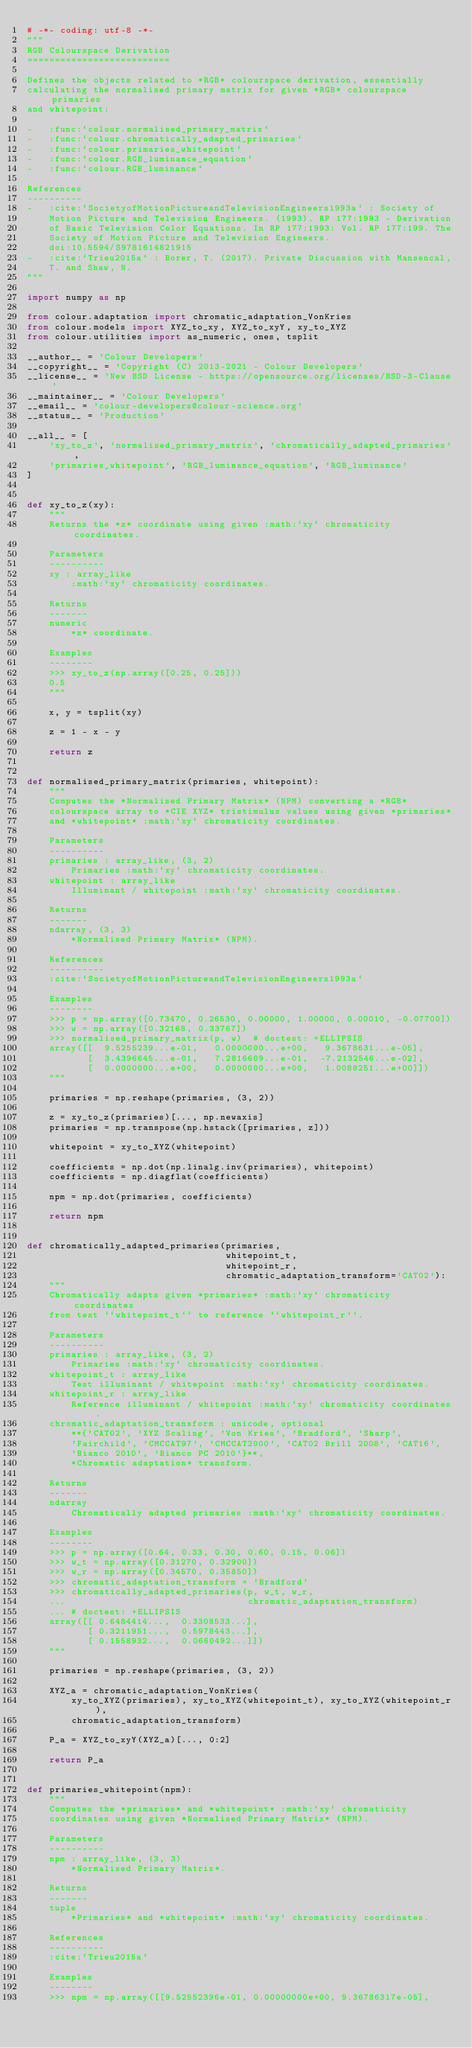Convert code to text. <code><loc_0><loc_0><loc_500><loc_500><_Python_># -*- coding: utf-8 -*-
"""
RGB Colourspace Derivation
==========================

Defines the objects related to *RGB* colourspace derivation, essentially
calculating the normalised primary matrix for given *RGB* colourspace primaries
and whitepoint:

-   :func:`colour.normalised_primary_matrix`
-   :func:`colour.chromatically_adapted_primaries`
-   :func:`colour.primaries_whitepoint`
-   :func:`colour.RGB_luminance_equation`
-   :func:`colour.RGB_luminance`

References
----------
-   :cite:`SocietyofMotionPictureandTelevisionEngineers1993a` : Society of
    Motion Picture and Television Engineers. (1993). RP 177:1993 - Derivation
    of Basic Television Color Equations. In RP 177:1993: Vol. RP 177:199. The
    Society of Motion Picture and Television Engineers.
    doi:10.5594/S9781614821915
-   :cite:`Trieu2015a` : Borer, T. (2017). Private Discussion with Mansencal,
    T. and Shaw, N.
"""

import numpy as np

from colour.adaptation import chromatic_adaptation_VonKries
from colour.models import XYZ_to_xy, XYZ_to_xyY, xy_to_XYZ
from colour.utilities import as_numeric, ones, tsplit

__author__ = 'Colour Developers'
__copyright__ = 'Copyright (C) 2013-2021 - Colour Developers'
__license__ = 'New BSD License - https://opensource.org/licenses/BSD-3-Clause'
__maintainer__ = 'Colour Developers'
__email__ = 'colour-developers@colour-science.org'
__status__ = 'Production'

__all__ = [
    'xy_to_z', 'normalised_primary_matrix', 'chromatically_adapted_primaries',
    'primaries_whitepoint', 'RGB_luminance_equation', 'RGB_luminance'
]


def xy_to_z(xy):
    """
    Returns the *z* coordinate using given :math:`xy` chromaticity coordinates.

    Parameters
    ----------
    xy : array_like
        :math:`xy` chromaticity coordinates.

    Returns
    -------
    numeric
        *z* coordinate.

    Examples
    --------
    >>> xy_to_z(np.array([0.25, 0.25]))
    0.5
    """

    x, y = tsplit(xy)

    z = 1 - x - y

    return z


def normalised_primary_matrix(primaries, whitepoint):
    """
    Computes the *Normalised Primary Matrix* (NPM) converting a *RGB*
    colourspace array to *CIE XYZ* tristimulus values using given *primaries*
    and *whitepoint* :math:`xy` chromaticity coordinates.

    Parameters
    ----------
    primaries : array_like, (3, 2)
        Primaries :math:`xy` chromaticity coordinates.
    whitepoint : array_like
        Illuminant / whitepoint :math:`xy` chromaticity coordinates.

    Returns
    -------
    ndarray, (3, 3)
        *Normalised Primary Matrix* (NPM).

    References
    ----------
    :cite:`SocietyofMotionPictureandTelevisionEngineers1993a`

    Examples
    --------
    >>> p = np.array([0.73470, 0.26530, 0.00000, 1.00000, 0.00010, -0.07700])
    >>> w = np.array([0.32168, 0.33767])
    >>> normalised_primary_matrix(p, w)  # doctest: +ELLIPSIS
    array([[  9.5255239...e-01,   0.0000000...e+00,   9.3678631...e-05],
           [  3.4396645...e-01,   7.2816609...e-01,  -7.2132546...e-02],
           [  0.0000000...e+00,   0.0000000...e+00,   1.0088251...e+00]])
    """

    primaries = np.reshape(primaries, (3, 2))

    z = xy_to_z(primaries)[..., np.newaxis]
    primaries = np.transpose(np.hstack([primaries, z]))

    whitepoint = xy_to_XYZ(whitepoint)

    coefficients = np.dot(np.linalg.inv(primaries), whitepoint)
    coefficients = np.diagflat(coefficients)

    npm = np.dot(primaries, coefficients)

    return npm


def chromatically_adapted_primaries(primaries,
                                    whitepoint_t,
                                    whitepoint_r,
                                    chromatic_adaptation_transform='CAT02'):
    """
    Chromatically adapts given *primaries* :math:`xy` chromaticity coordinates
    from test ``whitepoint_t`` to reference ``whitepoint_r``.

    Parameters
    ----------
    primaries : array_like, (3, 2)
        Primaries :math:`xy` chromaticity coordinates.
    whitepoint_t : array_like
        Test illuminant / whitepoint :math:`xy` chromaticity coordinates.
    whitepoint_r : array_like
        Reference illuminant / whitepoint :math:`xy` chromaticity coordinates.
    chromatic_adaptation_transform : unicode, optional
        **{'CAT02', 'XYZ Scaling', 'Von Kries', 'Bradford', 'Sharp',
        'Fairchild', 'CMCCAT97', 'CMCCAT2000', 'CAT02 Brill 2008', 'CAT16',
        'Bianco 2010', 'Bianco PC 2010'}**,
        *Chromatic adaptation* transform.

    Returns
    -------
    ndarray
        Chromatically adapted primaries :math:`xy` chromaticity coordinates.

    Examples
    --------
    >>> p = np.array([0.64, 0.33, 0.30, 0.60, 0.15, 0.06])
    >>> w_t = np.array([0.31270, 0.32900])
    >>> w_r = np.array([0.34570, 0.35850])
    >>> chromatic_adaptation_transform = 'Bradford'
    >>> chromatically_adapted_primaries(p, w_t, w_r,
    ...                                 chromatic_adaptation_transform)
    ... # doctest: +ELLIPSIS
    array([[ 0.6484414...,  0.3308533...],
           [ 0.3211951...,  0.5978443...],
           [ 0.1558932...,  0.0660492...]])
    """

    primaries = np.reshape(primaries, (3, 2))

    XYZ_a = chromatic_adaptation_VonKries(
        xy_to_XYZ(primaries), xy_to_XYZ(whitepoint_t), xy_to_XYZ(whitepoint_r),
        chromatic_adaptation_transform)

    P_a = XYZ_to_xyY(XYZ_a)[..., 0:2]

    return P_a


def primaries_whitepoint(npm):
    """
    Computes the *primaries* and *whitepoint* :math:`xy` chromaticity
    coordinates using given *Normalised Primary Matrix* (NPM).

    Parameters
    ----------
    npm : array_like, (3, 3)
        *Normalised Primary Matrix*.

    Returns
    -------
    tuple
        *Primaries* and *whitepoint* :math:`xy` chromaticity coordinates.

    References
    ----------
    :cite:`Trieu2015a`

    Examples
    --------
    >>> npm = np.array([[9.52552396e-01, 0.00000000e+00, 9.36786317e-05],</code> 